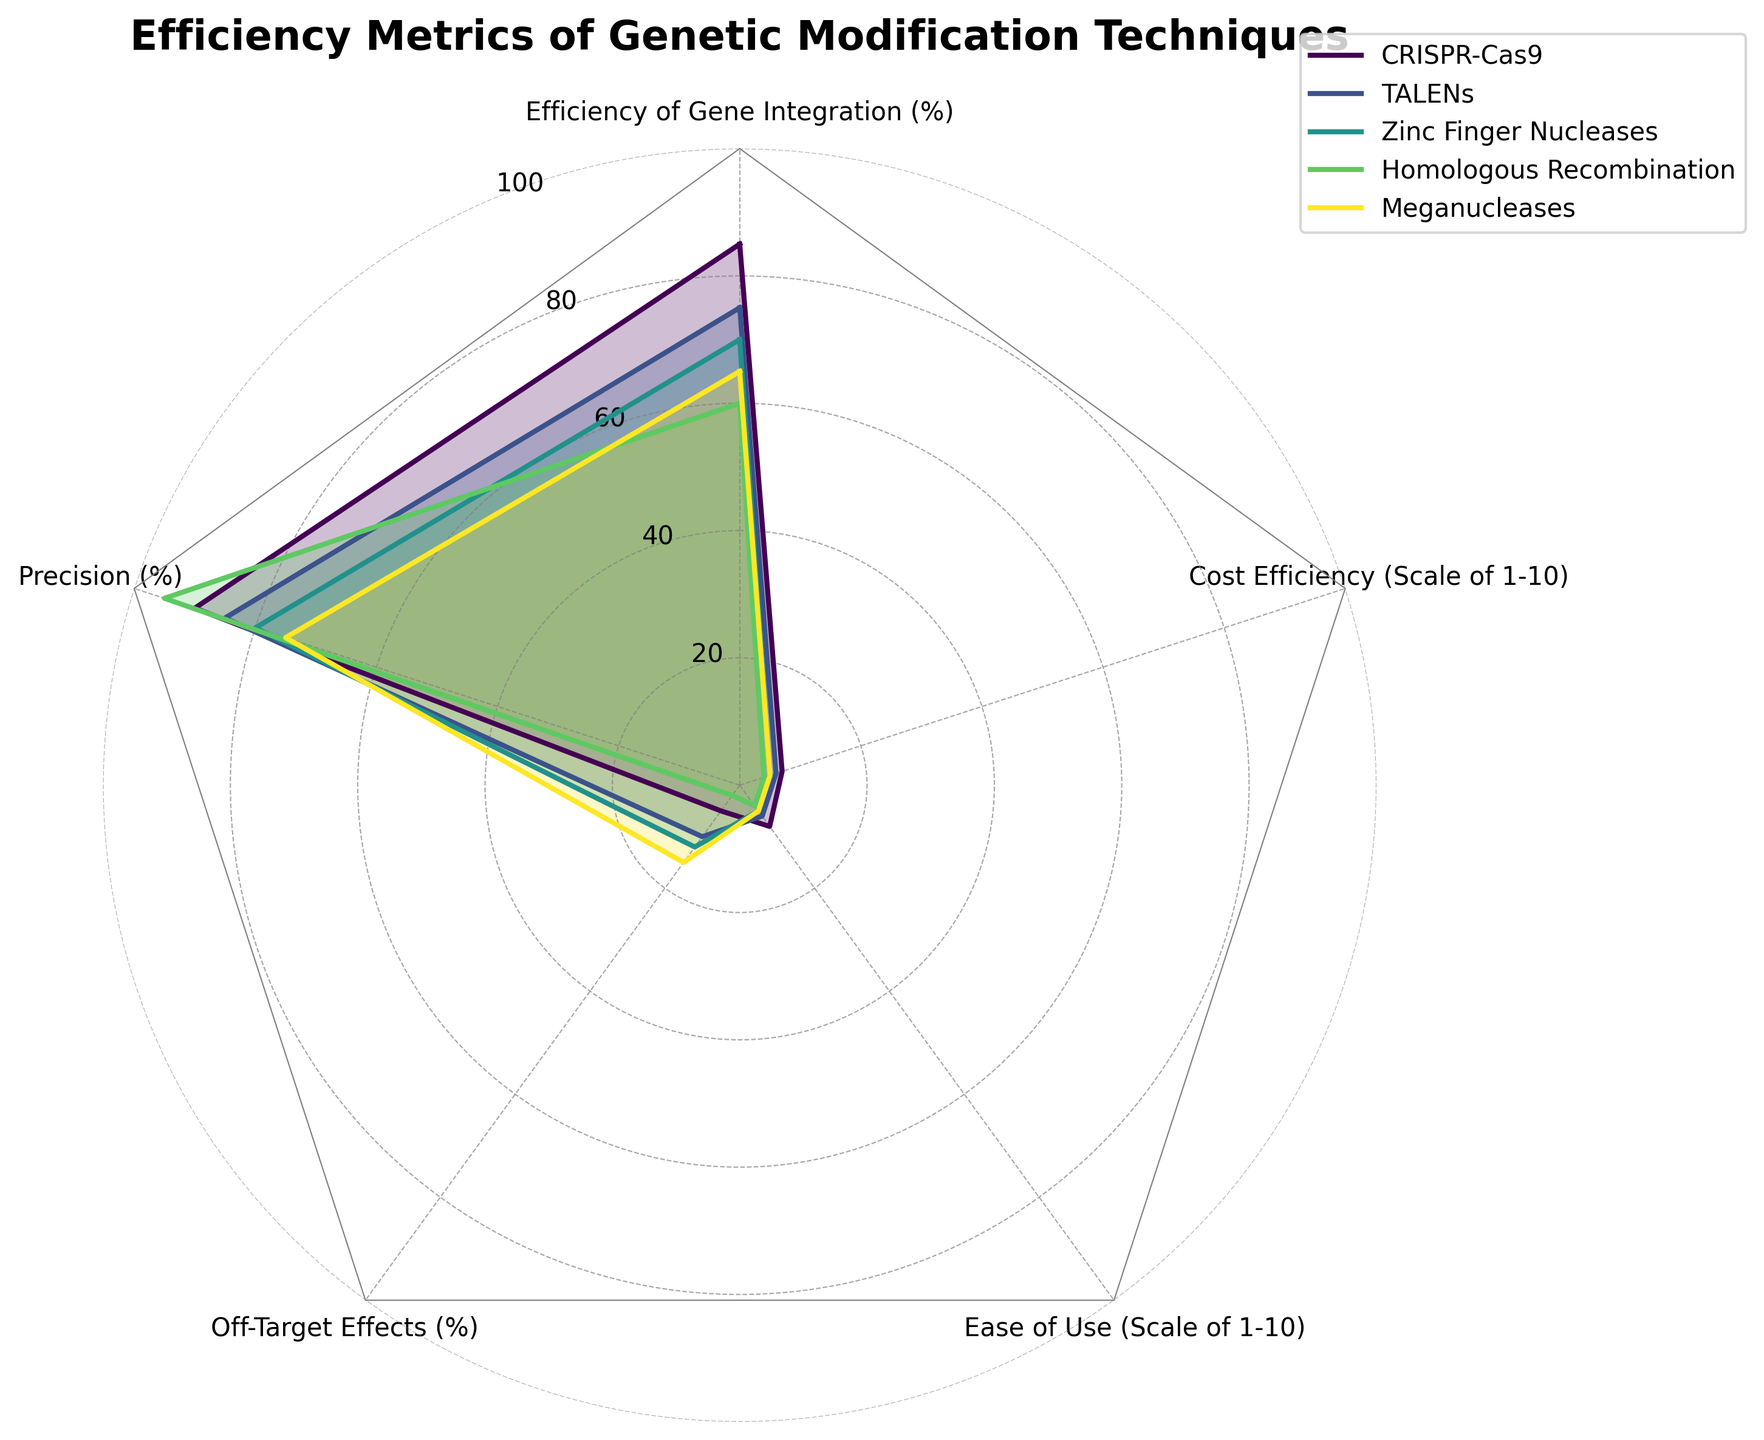What is the title of the radar chart? The title is typically placed at the top of the chart and indicates the main subject of the visualization. In this case, it reads "Efficiency Metrics of Genetic Modification Techniques".
Answer: Efficiency Metrics of Genetic Modification Techniques Which technique has the highest precision percentage according to the radar chart? Precision percentage is one of the metrics shown in the radar chart. By identifying the outermost end of the "Precision (%)" axis, we can see that "Homologous Recombination" is at 95%.
Answer: Homologous Recombination Among CRISPR-Cas9 and Zinc Finger Nucleases, which method shows higher ease of use? The "Ease of Use" metric, scaled from 1 to 10, indicates how user-friendly each technique is. CRISPR-Cas9 is rated 8, while Zinc Finger Nucleases is rated 5. CRISPR-Cas9 is the higher-rated technique.
Answer: CRISPR-Cas9 What is the total percentage of off-target effects for all techniques combined? To find the total off-target effects, we add the percentages of all techniques: CRISPR-Cas9 (5%) + TALENs (10%) + Zinc Finger Nucleases (12%) + Homologous Recombination (2%) + Meganucleases (15%). Adding these gives 44%.
Answer: 44% Which technique exhibits the lowest efficiency of gene integration? Examination of the "Efficiency of Gene Integration (%)" axis shows that "Homologous Recombination" is at 60%, which is the lowest among the provided techniques.
Answer: Homologous Recombination What is the average cost efficiency score for all techniques featured in the radar chart? The Cost Efficiency scores are on a scale of 1 to 10. We sum these scores: CRISPR-Cas9 (7) + TALENs (6) + Zinc Finger Nucleases (5) + Homologous Recombination (4) + Meganucleases (5). The total is 27, and the average is 27/5 = 5.4.
Answer: 5.4 